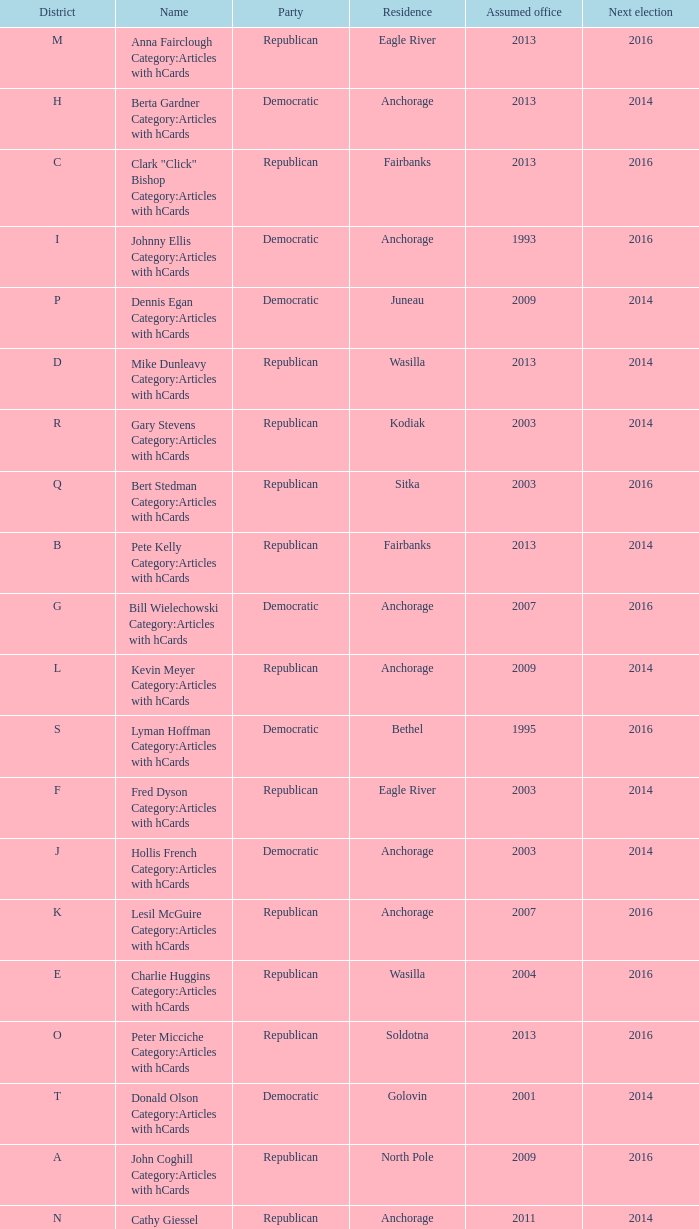What is the name of the Senator in the O District who assumed office in 2013? Peter Micciche Category:Articles with hCards. 